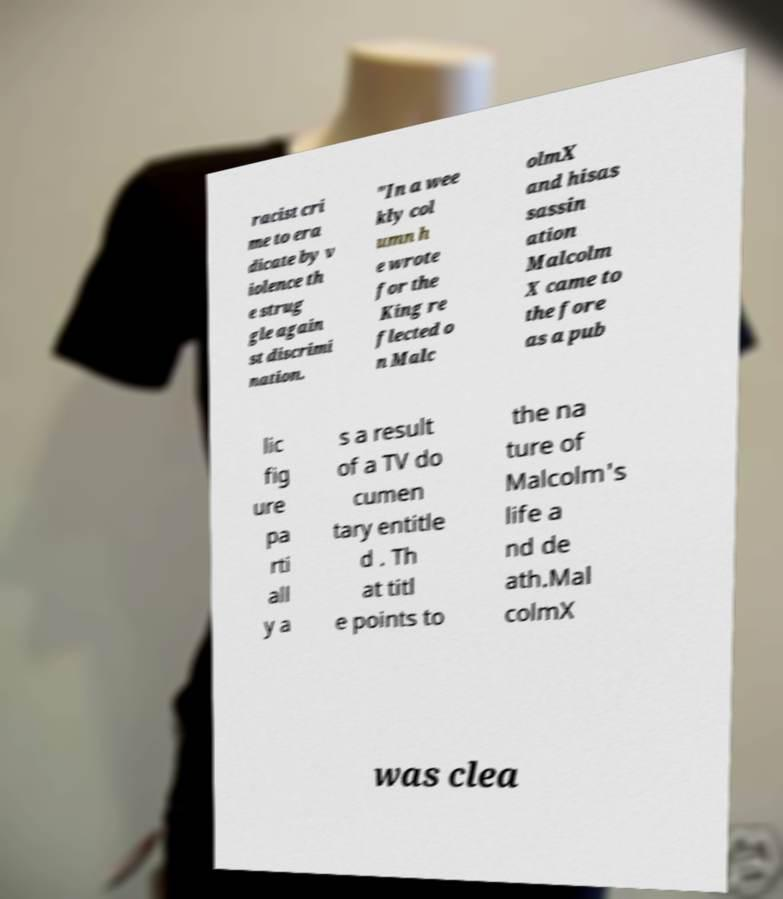What messages or text are displayed in this image? I need them in a readable, typed format. racist cri me to era dicate by v iolence th e strug gle again st discrimi nation. "In a wee kly col umn h e wrote for the King re flected o n Malc olmX and hisas sassin ation Malcolm X came to the fore as a pub lic fig ure pa rti all y a s a result of a TV do cumen tary entitle d . Th at titl e points to the na ture of Malcolm's life a nd de ath.Mal colmX was clea 